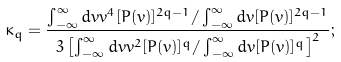Convert formula to latex. <formula><loc_0><loc_0><loc_500><loc_500>\kappa _ { q } = \frac { \int _ { - \infty } ^ { \infty } d v v ^ { 4 } [ P ( v ) ] ^ { 2 q - 1 } / \int _ { - \infty } ^ { \infty } d v [ P ( v ) ] ^ { 2 q - 1 } } { 3 \left [ \int _ { - \infty } ^ { \infty } d v v ^ { 2 } [ P ( v ) ] ^ { q } / \int _ { - \infty } ^ { \infty } d v [ P ( v ) ] ^ { q } \right ] ^ { 2 } } ;</formula> 